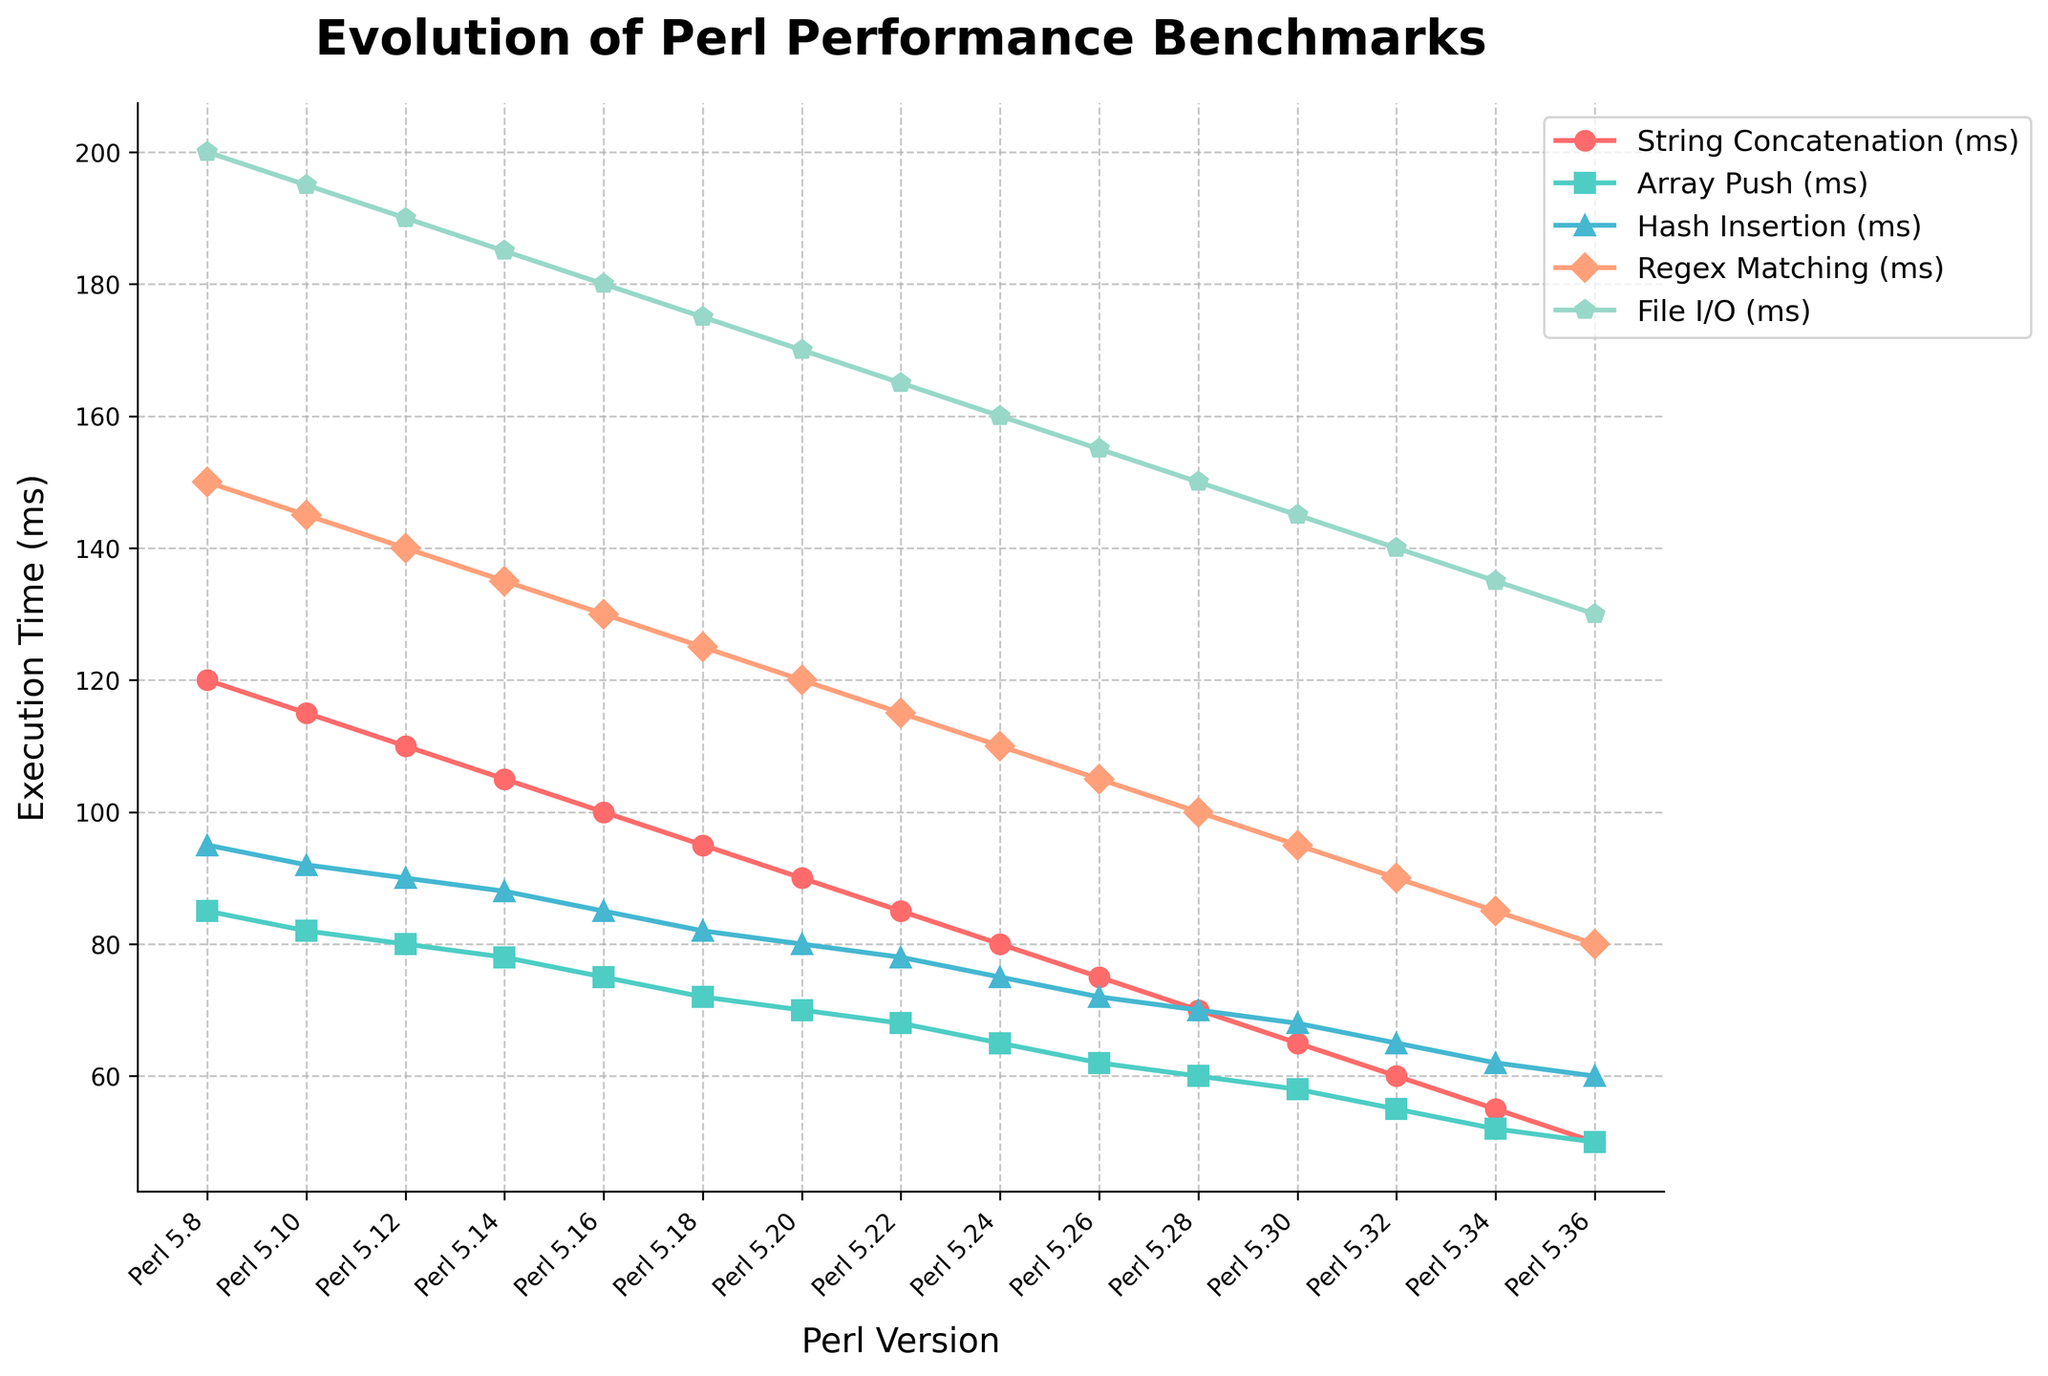What is the execution time for "String Concatenation" in Perl 5.34? To find the execution time for "String Concatenation" in Perl version 5.34, locate the 5.34 on the x-axis and follow it up to the "String Concatenation" line, which is color-coded in red. The corresponding y-axis value indicates the execution time.
Answer: 55 ms Which Perl version has the fastest "Array Push" operation? Identify the "Array Push" line, which is marked in green. Look for the data point with the lowest value on this line and note the corresponding Perl version on the x-axis. The lowest point matches the fastest execution time.
Answer: Perl 5.36 By how much does the execution time for "Regex Matching" decrease from Perl 5.8 to Perl 5.36? Start by finding the execution time for "Regex Matching" in Perl 5.8 (150 ms). Then, locate the execution time for the same operation in Perl 5.36 (80 ms). Calculate the change by subtracting the latter from the former: 150 ms - 80 ms = 70 ms.
Answer: 70 ms Which operation shows the most improvement in execution time from Perl 5.8 to Perl 5.36? Compare the changes in execution times for all operations between Perl 5.8 and Perl 5.36. Calculate the difference for each operation and identify the one with the largest decrease.
Answer: String Concatenation What is the average execution time for "File I/O" across all Perl versions shown in the chart? Sum up the "File I/O" execution times for all versions: (200 + 195 + 190 + 185 + 180 + 175 + 170 + 165 + 160 + 155 + 150 + 145 + 140 + 135 + 130) and divide the total by the number of entries. The total is 2435, and with 15 versions, the average is 2435 / 15 = 162.33 ms.
Answer: 162.33 ms Which operation had nearly consistent improvements in each subsequent Perl version? Look at the trends for all operations and identify the one where the line consistently slopes downward with minimal fluctuation. This consistent descent indicates regular improvement in execution time.
Answer: String Concatenation At which Perl version do all operations collectively show the lowest execution times? Compare the culmination of all execution times at each Perl version. The version where each operation's time is at its minimum is chosen. From the chart, Perl 5.36 displays collectively the lowest times for all operations.
Answer: Perl 5.36 How much faster is "Hash Insertion" in Perl 5.20 compared to Perl 5.10? Check the execution time for "Hash Insertion" in Perl 5.10 (92 ms) and Perl 5.20 (80 ms). The difference is calculated as 92 ms - 80 ms = 12 ms faster.
Answer: 12 ms What is the visual trend for "Regex Matching" across the versions? The trend line for "Regex Matching," marked in orange, should be observed across the versions. By following this line from Perl 5.8 to Perl 5.36, it shows a downward-sloping trend, indicating improved performance consistently across versions.
Answer: Downward trend Which operation had the least amount of total improvement across all Perl versions? By comparing the total amount of execution time reduction for each operation from Perl 5.8 to Perl 5.36, the operation with the smallest difference is identified. Calculate the differences to find that "File I/O" shows the least total improvement.
Answer: File I/O 